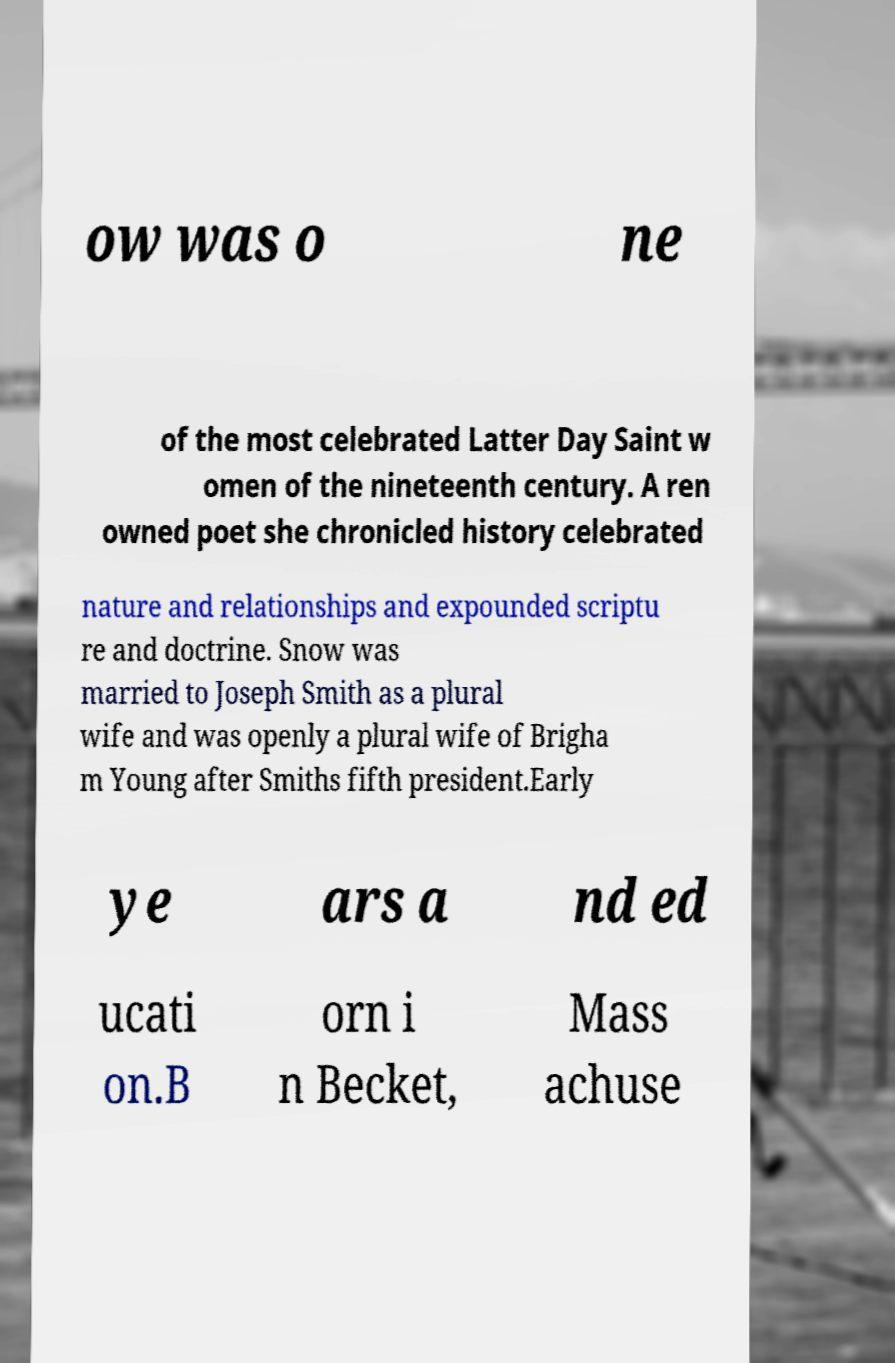I need the written content from this picture converted into text. Can you do that? ow was o ne of the most celebrated Latter Day Saint w omen of the nineteenth century. A ren owned poet she chronicled history celebrated nature and relationships and expounded scriptu re and doctrine. Snow was married to Joseph Smith as a plural wife and was openly a plural wife of Brigha m Young after Smiths fifth president.Early ye ars a nd ed ucati on.B orn i n Becket, Mass achuse 